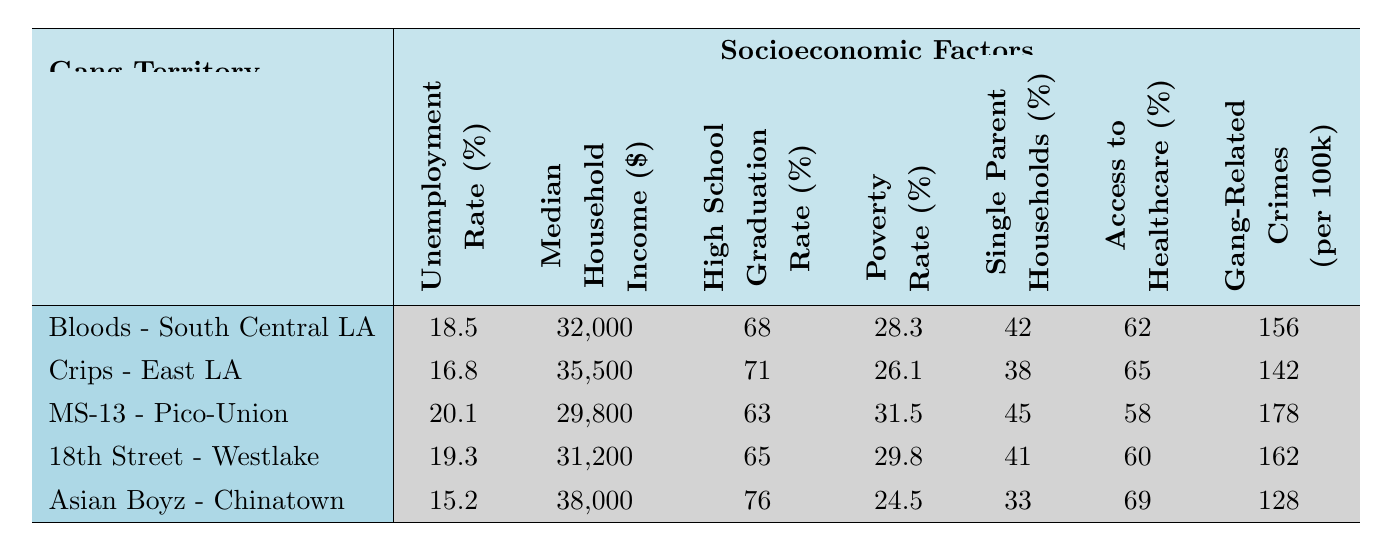What is the unemployment rate in the Bloods Territory? The unemployment rate for the Bloods Territory, listed in the table, is directly referenced. It is shown under the column for Unemployment Rate (%) next to the Bloods Territory.
Answer: 18.5% Which gang territory has the highest median household income? By comparing the median household income values from all territories, we see that the Asian Boyz Territory has the highest income at $38,000.
Answer: Asian Boyz Territory - Chinatown What is the poverty rate in MS-13 Territory? The table indicates that the poverty rate for the MS-13 Territory is listed under the Poverty Rate (%) column, specifically for this territory.
Answer: 31.5% What is the average high school graduation rate across all territories? To find the average high school graduation rate, add the graduation rates of all territories: (68 + 71 + 63 + 65 + 76) = 343. Then divide by the number of territories, which is 5. Thus, 343 / 5 = 68.6.
Answer: 68.6% Is the access to healthcare in East LA higher than in South Central LA? The access to healthcare percentage in the Crips Territory (East LA) is 65%, while in the Bloods Territory (South Central LA) it is 62%. Since 65% is greater than 62%, the statement is true.
Answer: Yes What percentage of households in the territory of 18th Street are single-parent households? The table shows that the percentage of single-parent households in the 18th Street Gang Territory is directly indicated in the Single Parent Households (%) column.
Answer: 41% Which territory has the lowest gang-related crimes per 100k? The gang-related crimes per 100k values should be compared. The Asian Boyz Territory has the lowest value listed as 128.
Answer: Asian Boyz Territory - Chinatown Calculate the difference in unemployment rates between the highest and lowest territories. The highest unemployment rate is in MS-13 Territory at 20.1%, and the lowest is in Asian Boyz Territory at 15.2%. The difference is 20.1 - 15.2 = 4.9.
Answer: 4.9% Is it true that all territories have a high school graduation rate below 80%? By checking each territory's high school graduation rate, only the Asian Boyz Territory has a rate of 76%, which is below 80%. Therefore, this statement holds true.
Answer: Yes What is the median income for the Crips Territory and how does it compare to the MS-13 Territory? The median household income for the Crips Territory is $35,500, and for the MS-13 Territory, it is $29,800. By comparing both, $35,500 is greater than $29,800, making the Crips Territory higher in income.
Answer: $35,500 (higher than MS-13) 